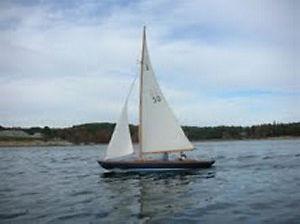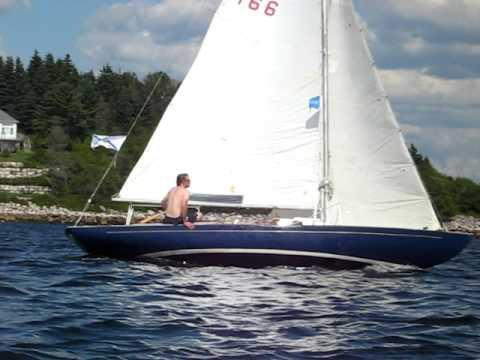The first image is the image on the left, the second image is the image on the right. Considering the images on both sides, is "In one of the images there is a lone person sailing a boat in the center of the image." valid? Answer yes or no. Yes. The first image is the image on the left, the second image is the image on the right. Examine the images to the left and right. Is the description "At least one of the boats has a white hull." accurate? Answer yes or no. No. 